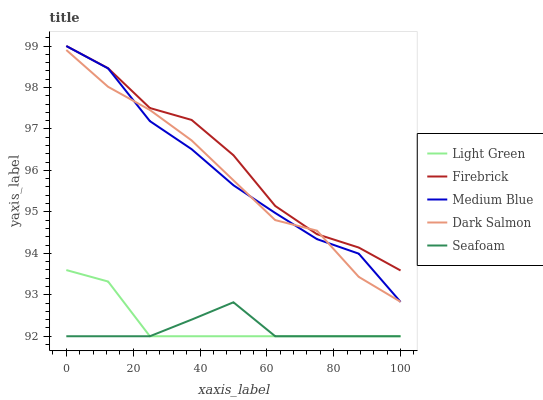Does Seafoam have the minimum area under the curve?
Answer yes or no. Yes. Does Firebrick have the maximum area under the curve?
Answer yes or no. Yes. Does Medium Blue have the minimum area under the curve?
Answer yes or no. No. Does Medium Blue have the maximum area under the curve?
Answer yes or no. No. Is Light Green the smoothest?
Answer yes or no. Yes. Is Firebrick the roughest?
Answer yes or no. Yes. Is Medium Blue the smoothest?
Answer yes or no. No. Is Medium Blue the roughest?
Answer yes or no. No. Does Medium Blue have the lowest value?
Answer yes or no. No. Does Dark Salmon have the highest value?
Answer yes or no. No. Is Light Green less than Dark Salmon?
Answer yes or no. Yes. Is Dark Salmon greater than Light Green?
Answer yes or no. Yes. Does Light Green intersect Dark Salmon?
Answer yes or no. No. 